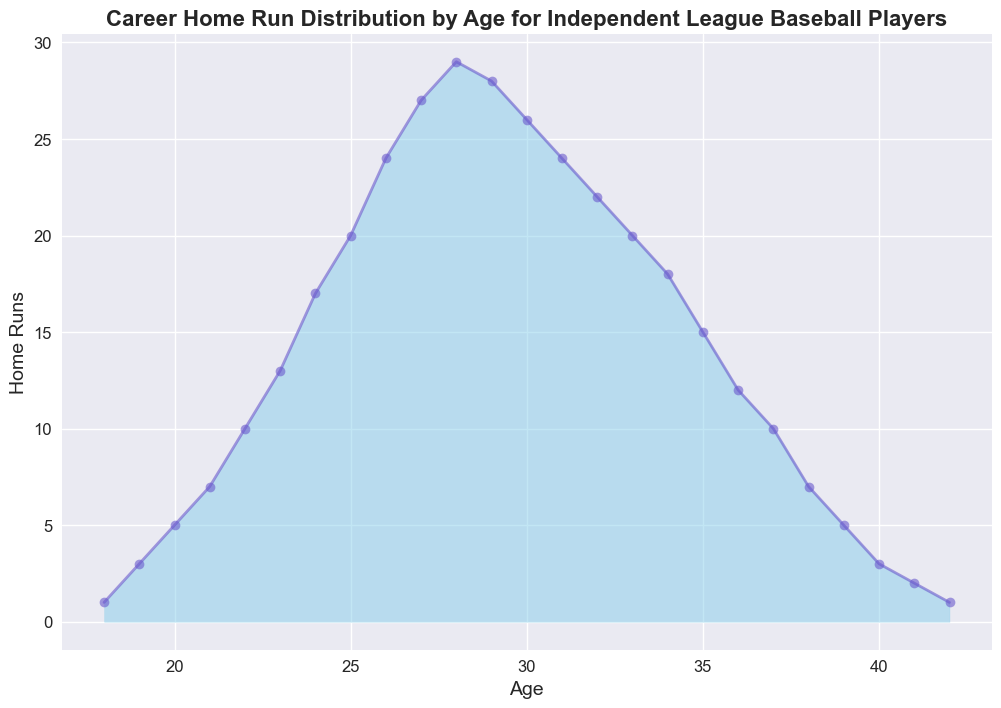What's the peak age for career home runs? To find the peak age, look for the age with the highest home run value on the y-axis. On the plot, the highest point is at age 28, where the home run count is 29.
Answer: 28 How many home runs are hit by players aged 26 and above in total? Sum the home runs for ages 26 and above: 24 (age 26) + 27 (age 27) + 29 (age 28) + 28 (age 29) + 26 (age 30) + 24 (age 31) + 22 (age 32) + 20 (age 33) + 18 (age 34) + 15 (age 35) + 12 (age 36) + 10 (age 37) + 7 (age 38) + 5 (age 39) + 3 (age 40) + 2 (age 41) + 1 (age 42). This sums to 273 home runs.
Answer: 273 What is the difference in home runs between ages 25 and 29? Look at the home run counts for ages 25 and 29: The home runs at age 25 are 20, and at age 29, they are 28. The difference is 28 - 20 = 8.
Answer: 8 Is the home run count greater at age 24 or age 30? Compare the home run counts at ages 24 and 30. For age 24, it is 17, and for age 30, it is 26. Age 30 has a greater home run count.
Answer: Age 30 Which age group has the steepest increase in home runs and what is the increase? To find the steepest increase, look for the age interval with the largest difference in home run count. The largest increase is from age 21 (7 home runs) to age 22 (10 home runs), with an increase of 3.
Answer: Age 21 to 22, increase of 3 What can you infer about the trend of home runs from ages 18 to 25? Observe the overall pattern from ages 18 to 25. The home run count steadily increases from 1 at age 18 to 20 at age 25. This implies a consistent upward trend in home runs during these ages.
Answer: Increases steadily Are there any ages where home run counts decrease consecutively? Inspect the home run counts for any consecutive decreases. Starting at age 28 (29 home runs), the count decreases consecutively until age 32 (22 home runs).
Answer: Yes, from age 28 to 32 What is the average number of home runs for players aged 18 to 22? Calculate the mean home runs for ages 18 to 22: (1+3+5+7+10) / 5 = 26 / 5 = 5.2.
Answer: 5.2 